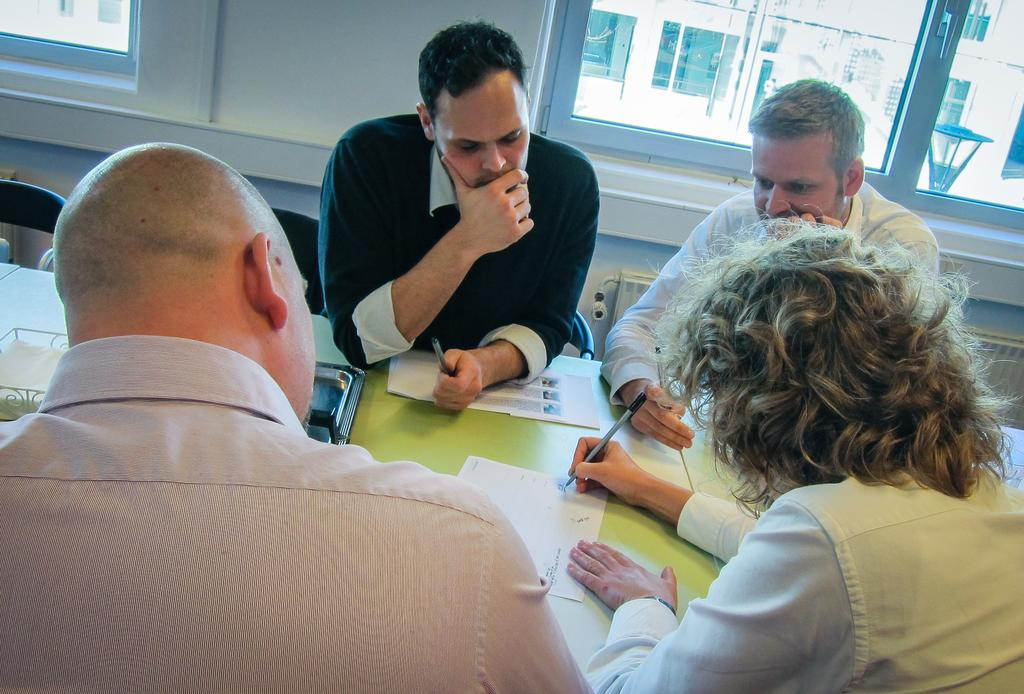What is the main object in the image? There is a table in the image. How many people are present around the table? There are four people around the table. What are the people doing in the image? The people are engaged in a discussion. What can be seen on the table besides the people? There are papers on the table. What is visible in the background of the image? There are windows in the background of the image. What type of neck is visible on the person sitting at the head of the table? There is no specific neck visible on any person in the image, as the image does not focus on individual features. 